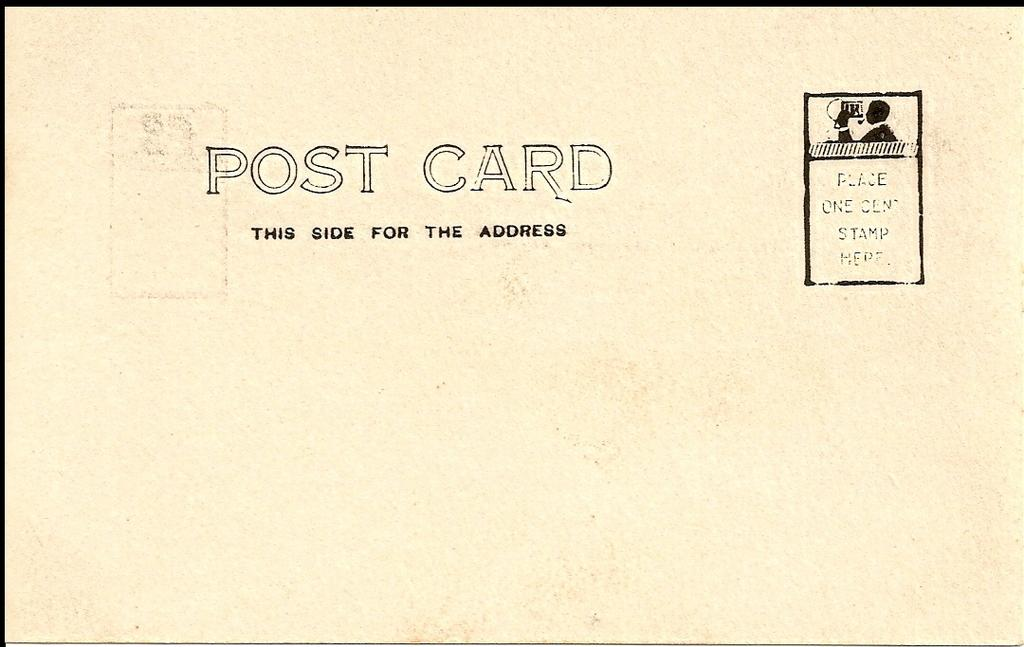<image>
Provide a brief description of the given image. A post card indicates where to put the address. 